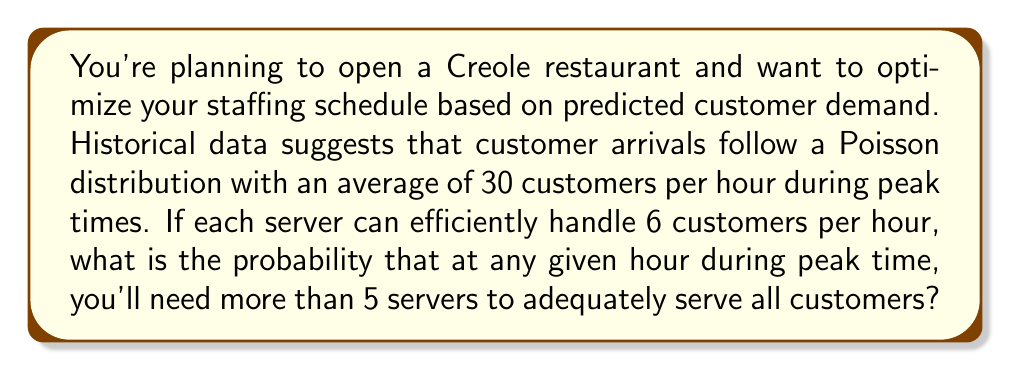What is the answer to this math problem? Let's approach this step-by-step:

1) First, we need to understand what the question is asking. We're looking for the probability that the number of customers in an hour exceeds the capacity of 5 servers.

2) Each server can handle 6 customers per hour, so 5 servers can handle 5 * 6 = 30 customers per hour.

3) Customer arrivals follow a Poisson distribution with λ = 30 (average of 30 customers per hour).

4) We need to find P(X > 30), where X is the number of customer arrivals in an hour.

5) For a Poisson distribution, this is equivalent to 1 - P(X ≤ 30).

6) The cumulative distribution function (CDF) of a Poisson distribution is given by:

   $$P(X \leq k) = e^{-\lambda} \sum_{i=0}^k \frac{\lambda^i}{i!}$$

7) In our case, λ = 30 and k = 30. So we need to calculate:

   $$1 - P(X \leq 30) = 1 - e^{-30} \sum_{i=0}^{30} \frac{30^i}{i!}$$

8) This calculation is complex to do by hand, so we typically use statistical software or tables. Using such a tool, we find that:

   $$P(X \leq 30) \approx 0.5595$$

9) Therefore, the probability we're looking for is:

   $$1 - 0.5595 = 0.4405$$

This means there's approximately a 44.05% chance that more than 5 servers will be needed in any given peak hour.
Answer: 0.4405 or 44.05% 